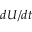Convert formula to latex. <formula><loc_0><loc_0><loc_500><loc_500>d U / d t</formula> 